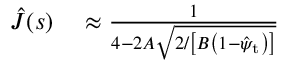Convert formula to latex. <formula><loc_0><loc_0><loc_500><loc_500>\begin{array} { r l } { \hat { J } ( s ) } & \approx \frac { 1 } { 4 - 2 A \sqrt { 2 / \left [ B \left ( 1 - \hat { \psi } _ { t } \right ) \right ] } } } \end{array}</formula> 